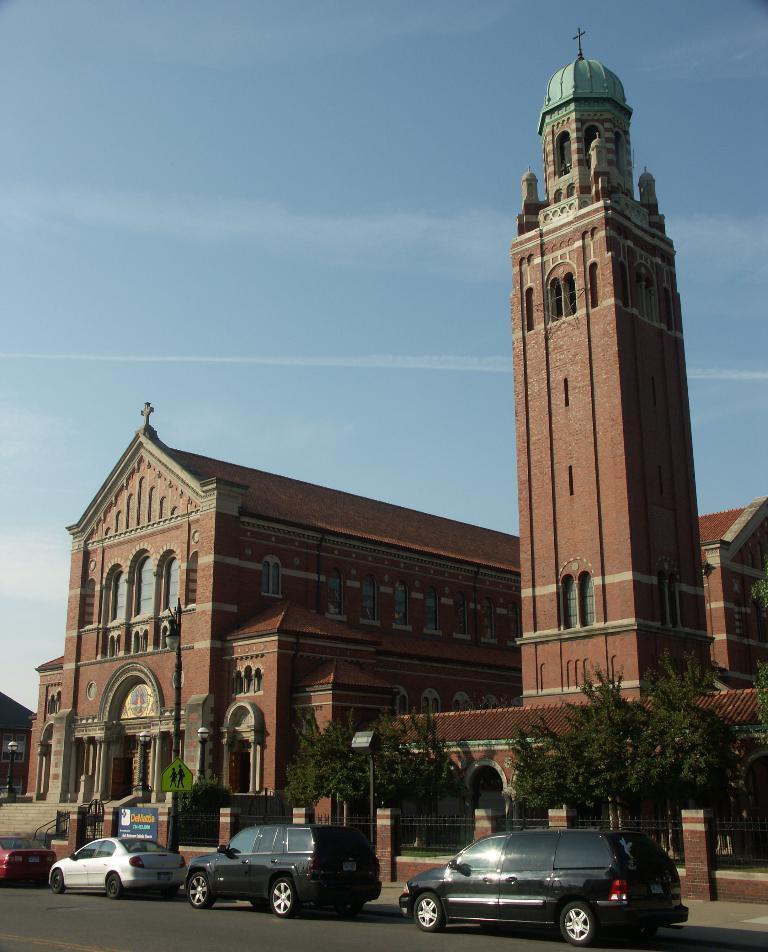Please provide a concise description of this image. This picture is clicked outside the city. At the bottom of the picture, we see cars moving on the road. Beside that, we see a blue board with some text written on it. We even see pillars and staircase. On the right side, we see a tree. In the background, there are churches. At the top of the picture, we see the sky. 